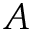Convert formula to latex. <formula><loc_0><loc_0><loc_500><loc_500>A</formula> 